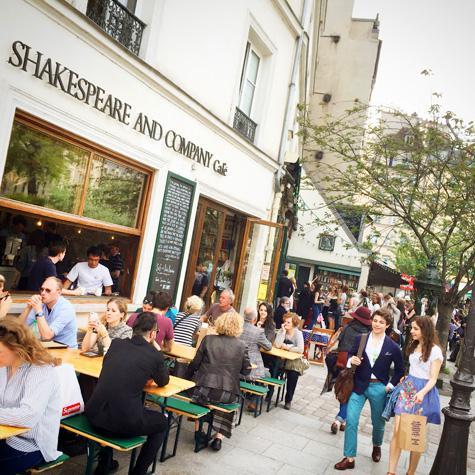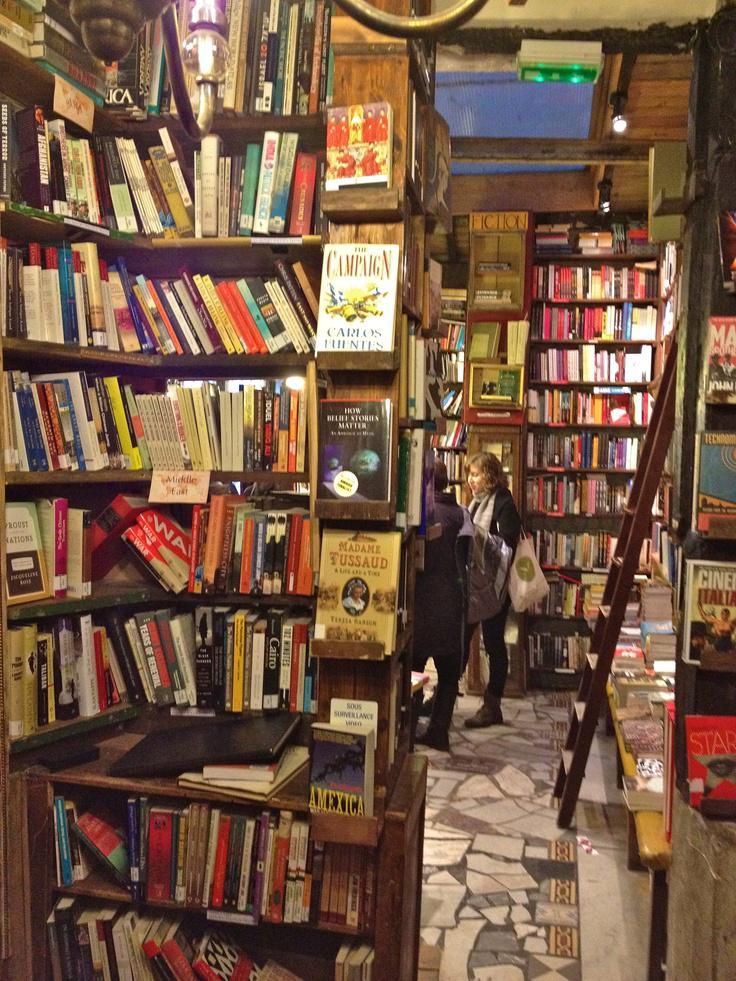The first image is the image on the left, the second image is the image on the right. Examine the images to the left and right. Is the description "There are people seated." accurate? Answer yes or no. Yes. The first image is the image on the left, the second image is the image on the right. Given the left and right images, does the statement "People are seated outside in a shopping area." hold true? Answer yes or no. Yes. 